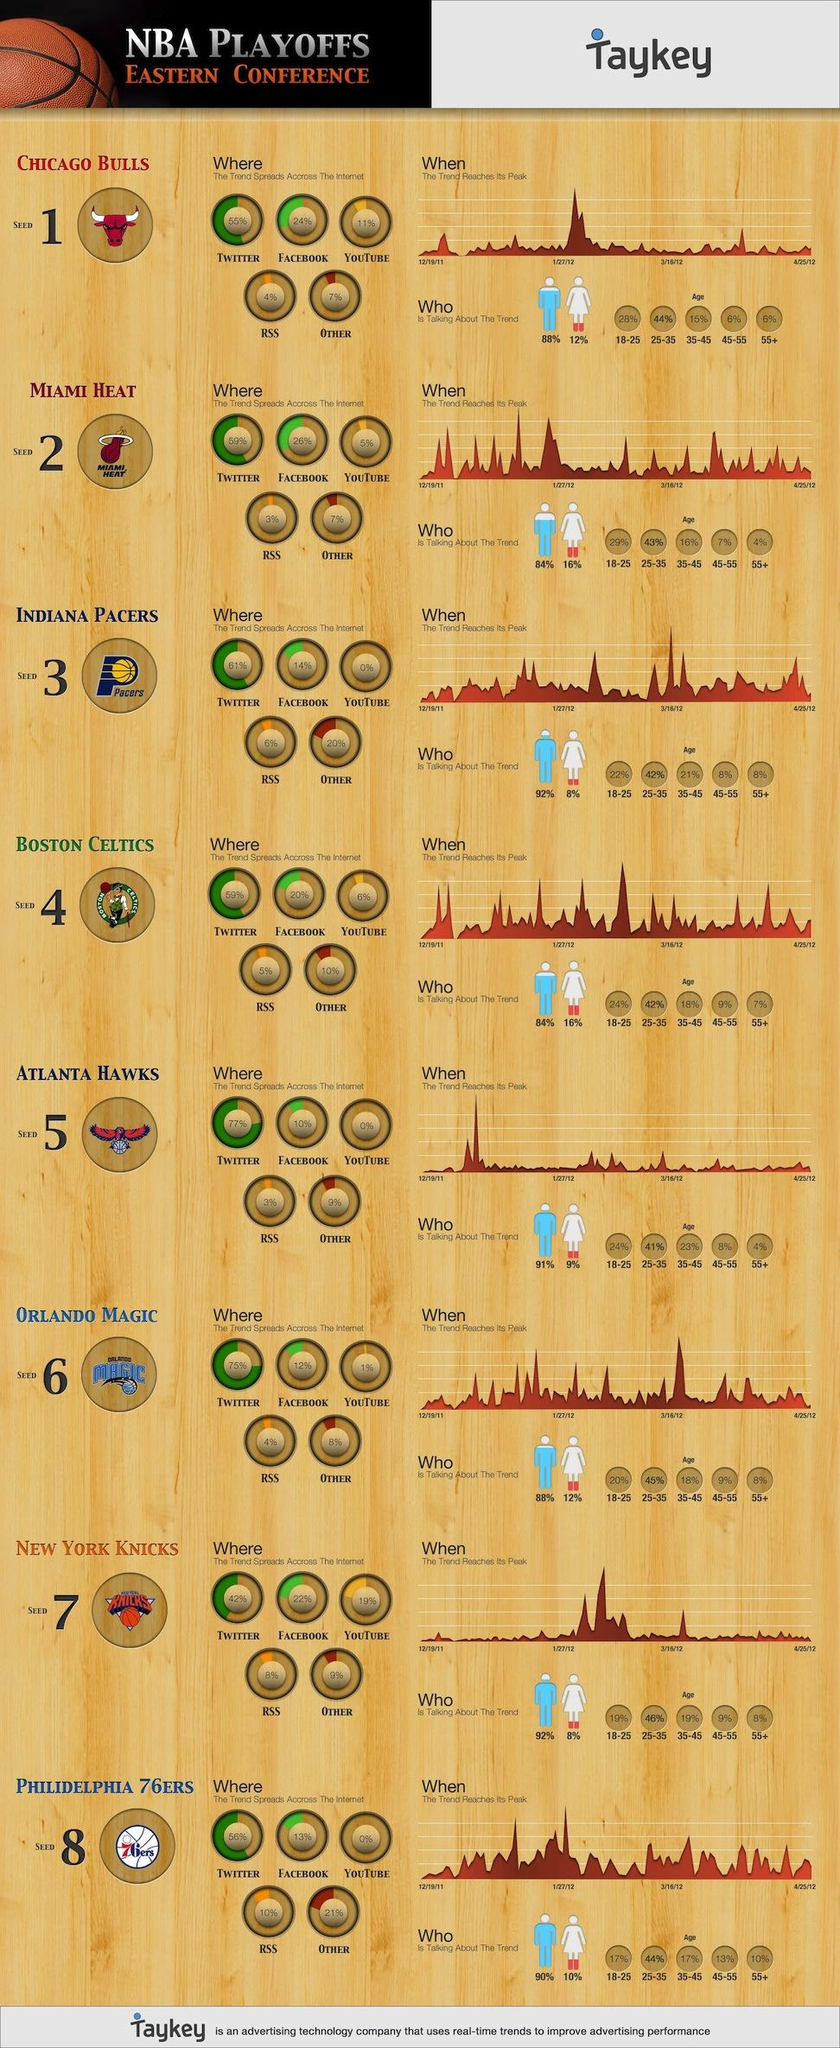Highlight a few significant elements in this photo. The logo of the Philadelphia 76ers contains the text '76ers,' which can be clearly seen and read. A recent survey has revealed that 12% of females are discussing the Orlando Magic. The percentage of Twitter and Facebook followers for the Chicago Bulls is 79%. According to recent data, approximately 12% of females are discussing the Chicago Bulls. The color of the ball in the logo of the New York Knicks is orange. 